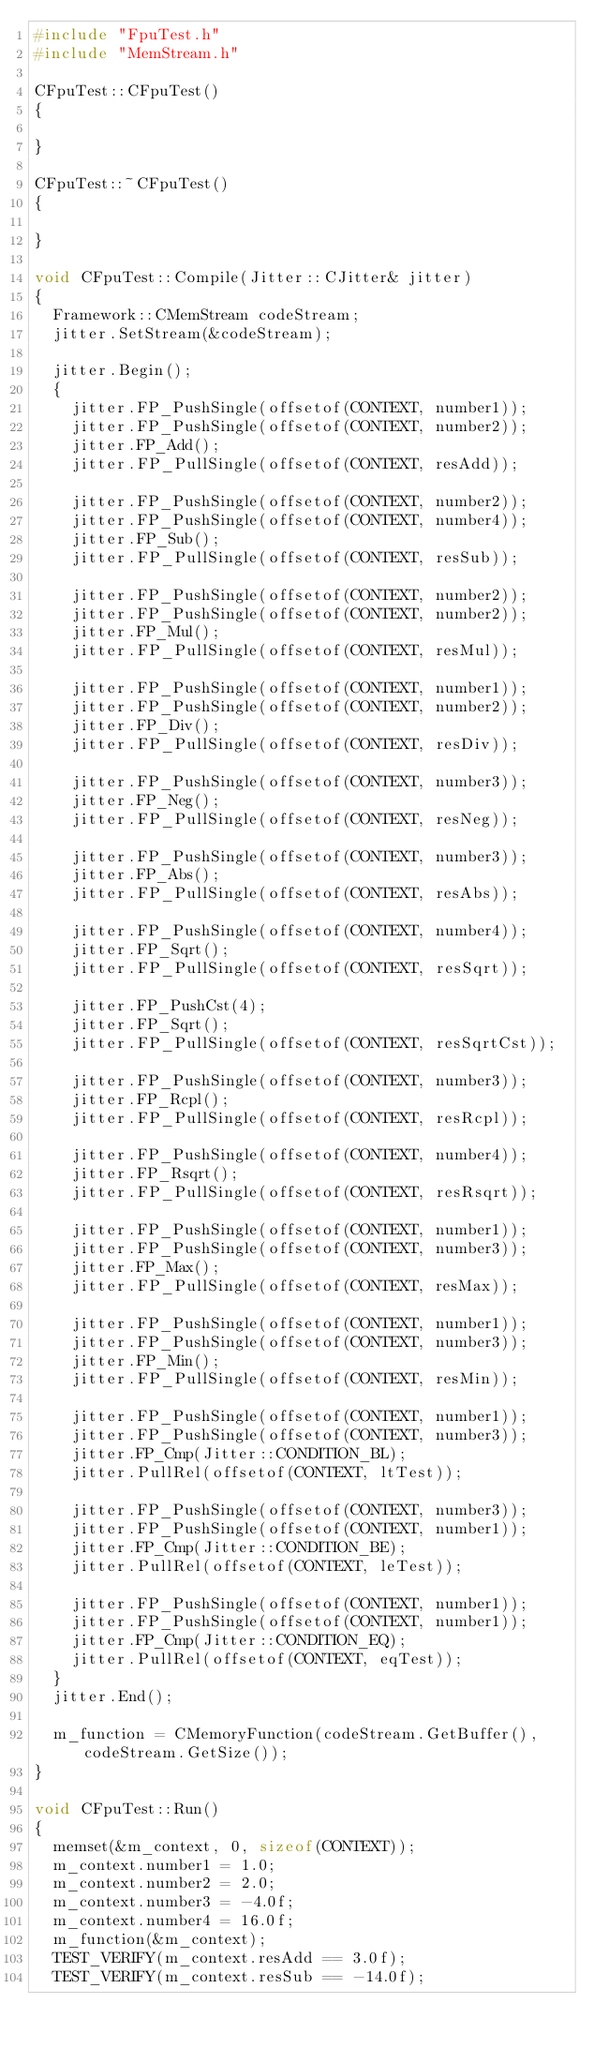<code> <loc_0><loc_0><loc_500><loc_500><_C++_>#include "FpuTest.h"
#include "MemStream.h"

CFpuTest::CFpuTest()
{

}

CFpuTest::~CFpuTest()
{

}

void CFpuTest::Compile(Jitter::CJitter& jitter)
{
	Framework::CMemStream codeStream;
	jitter.SetStream(&codeStream);

	jitter.Begin();
	{
		jitter.FP_PushSingle(offsetof(CONTEXT, number1));
		jitter.FP_PushSingle(offsetof(CONTEXT, number2));
		jitter.FP_Add();
		jitter.FP_PullSingle(offsetof(CONTEXT, resAdd));

		jitter.FP_PushSingle(offsetof(CONTEXT, number2));
		jitter.FP_PushSingle(offsetof(CONTEXT, number4));
		jitter.FP_Sub();
		jitter.FP_PullSingle(offsetof(CONTEXT, resSub));

		jitter.FP_PushSingle(offsetof(CONTEXT, number2));
		jitter.FP_PushSingle(offsetof(CONTEXT, number2));
		jitter.FP_Mul();
		jitter.FP_PullSingle(offsetof(CONTEXT, resMul));

		jitter.FP_PushSingle(offsetof(CONTEXT, number1));
		jitter.FP_PushSingle(offsetof(CONTEXT, number2));
		jitter.FP_Div();
		jitter.FP_PullSingle(offsetof(CONTEXT, resDiv));

		jitter.FP_PushSingle(offsetof(CONTEXT, number3));
		jitter.FP_Neg();
		jitter.FP_PullSingle(offsetof(CONTEXT, resNeg));

		jitter.FP_PushSingle(offsetof(CONTEXT, number3));
		jitter.FP_Abs();
		jitter.FP_PullSingle(offsetof(CONTEXT, resAbs));

		jitter.FP_PushSingle(offsetof(CONTEXT, number4));
		jitter.FP_Sqrt();
		jitter.FP_PullSingle(offsetof(CONTEXT, resSqrt));

		jitter.FP_PushCst(4);
		jitter.FP_Sqrt();
		jitter.FP_PullSingle(offsetof(CONTEXT, resSqrtCst));

		jitter.FP_PushSingle(offsetof(CONTEXT, number3));
		jitter.FP_Rcpl();
		jitter.FP_PullSingle(offsetof(CONTEXT, resRcpl));

		jitter.FP_PushSingle(offsetof(CONTEXT, number4));
		jitter.FP_Rsqrt();
		jitter.FP_PullSingle(offsetof(CONTEXT, resRsqrt));

		jitter.FP_PushSingle(offsetof(CONTEXT, number1));
		jitter.FP_PushSingle(offsetof(CONTEXT, number3));
		jitter.FP_Max();
		jitter.FP_PullSingle(offsetof(CONTEXT, resMax));

		jitter.FP_PushSingle(offsetof(CONTEXT, number1));
		jitter.FP_PushSingle(offsetof(CONTEXT, number3));
		jitter.FP_Min();
		jitter.FP_PullSingle(offsetof(CONTEXT, resMin));

		jitter.FP_PushSingle(offsetof(CONTEXT, number1));
		jitter.FP_PushSingle(offsetof(CONTEXT, number3));
		jitter.FP_Cmp(Jitter::CONDITION_BL);
		jitter.PullRel(offsetof(CONTEXT, ltTest));

		jitter.FP_PushSingle(offsetof(CONTEXT, number3));
		jitter.FP_PushSingle(offsetof(CONTEXT, number1));
		jitter.FP_Cmp(Jitter::CONDITION_BE);
		jitter.PullRel(offsetof(CONTEXT, leTest));

		jitter.FP_PushSingle(offsetof(CONTEXT, number1));
		jitter.FP_PushSingle(offsetof(CONTEXT, number1));
		jitter.FP_Cmp(Jitter::CONDITION_EQ);
		jitter.PullRel(offsetof(CONTEXT, eqTest));
	}
	jitter.End();

	m_function = CMemoryFunction(codeStream.GetBuffer(), codeStream.GetSize());
}

void CFpuTest::Run()
{
	memset(&m_context, 0, sizeof(CONTEXT));
	m_context.number1 = 1.0;
	m_context.number2 = 2.0;
	m_context.number3 = -4.0f;
	m_context.number4 = 16.0f;
	m_function(&m_context);
	TEST_VERIFY(m_context.resAdd == 3.0f);
	TEST_VERIFY(m_context.resSub == -14.0f);</code> 